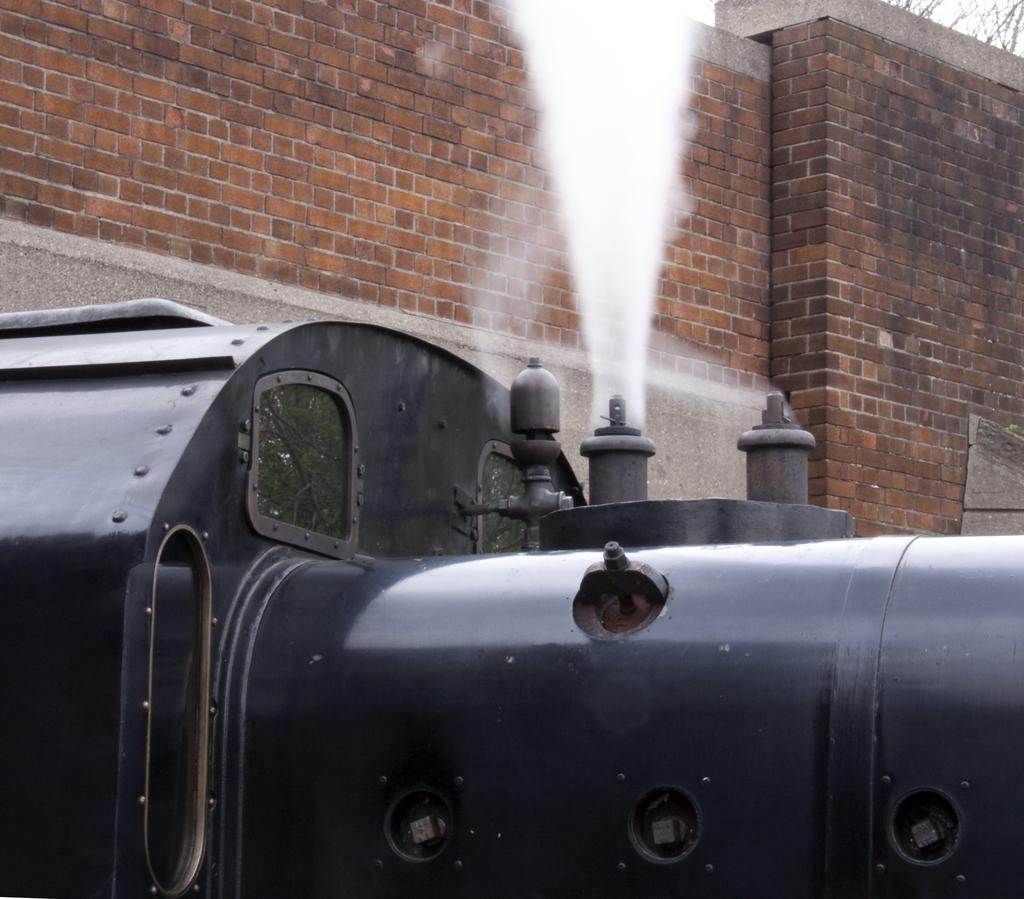What type of vehicle is in the image? There is a steam engine in the image. What other objects can be seen in the image? There are glass objects in the image. What is coming out of the steam engine? Smoke is visible in the image. What is in the background of the image? There is a brick wall in the background of the image. What can be seen in the reflections of the glass objects? The glass objects have reflections of trees. What type of authority figure is present in the image? There is no authority figure present in the image. What type of whip is being used in the image? There is no whip present in the image. 